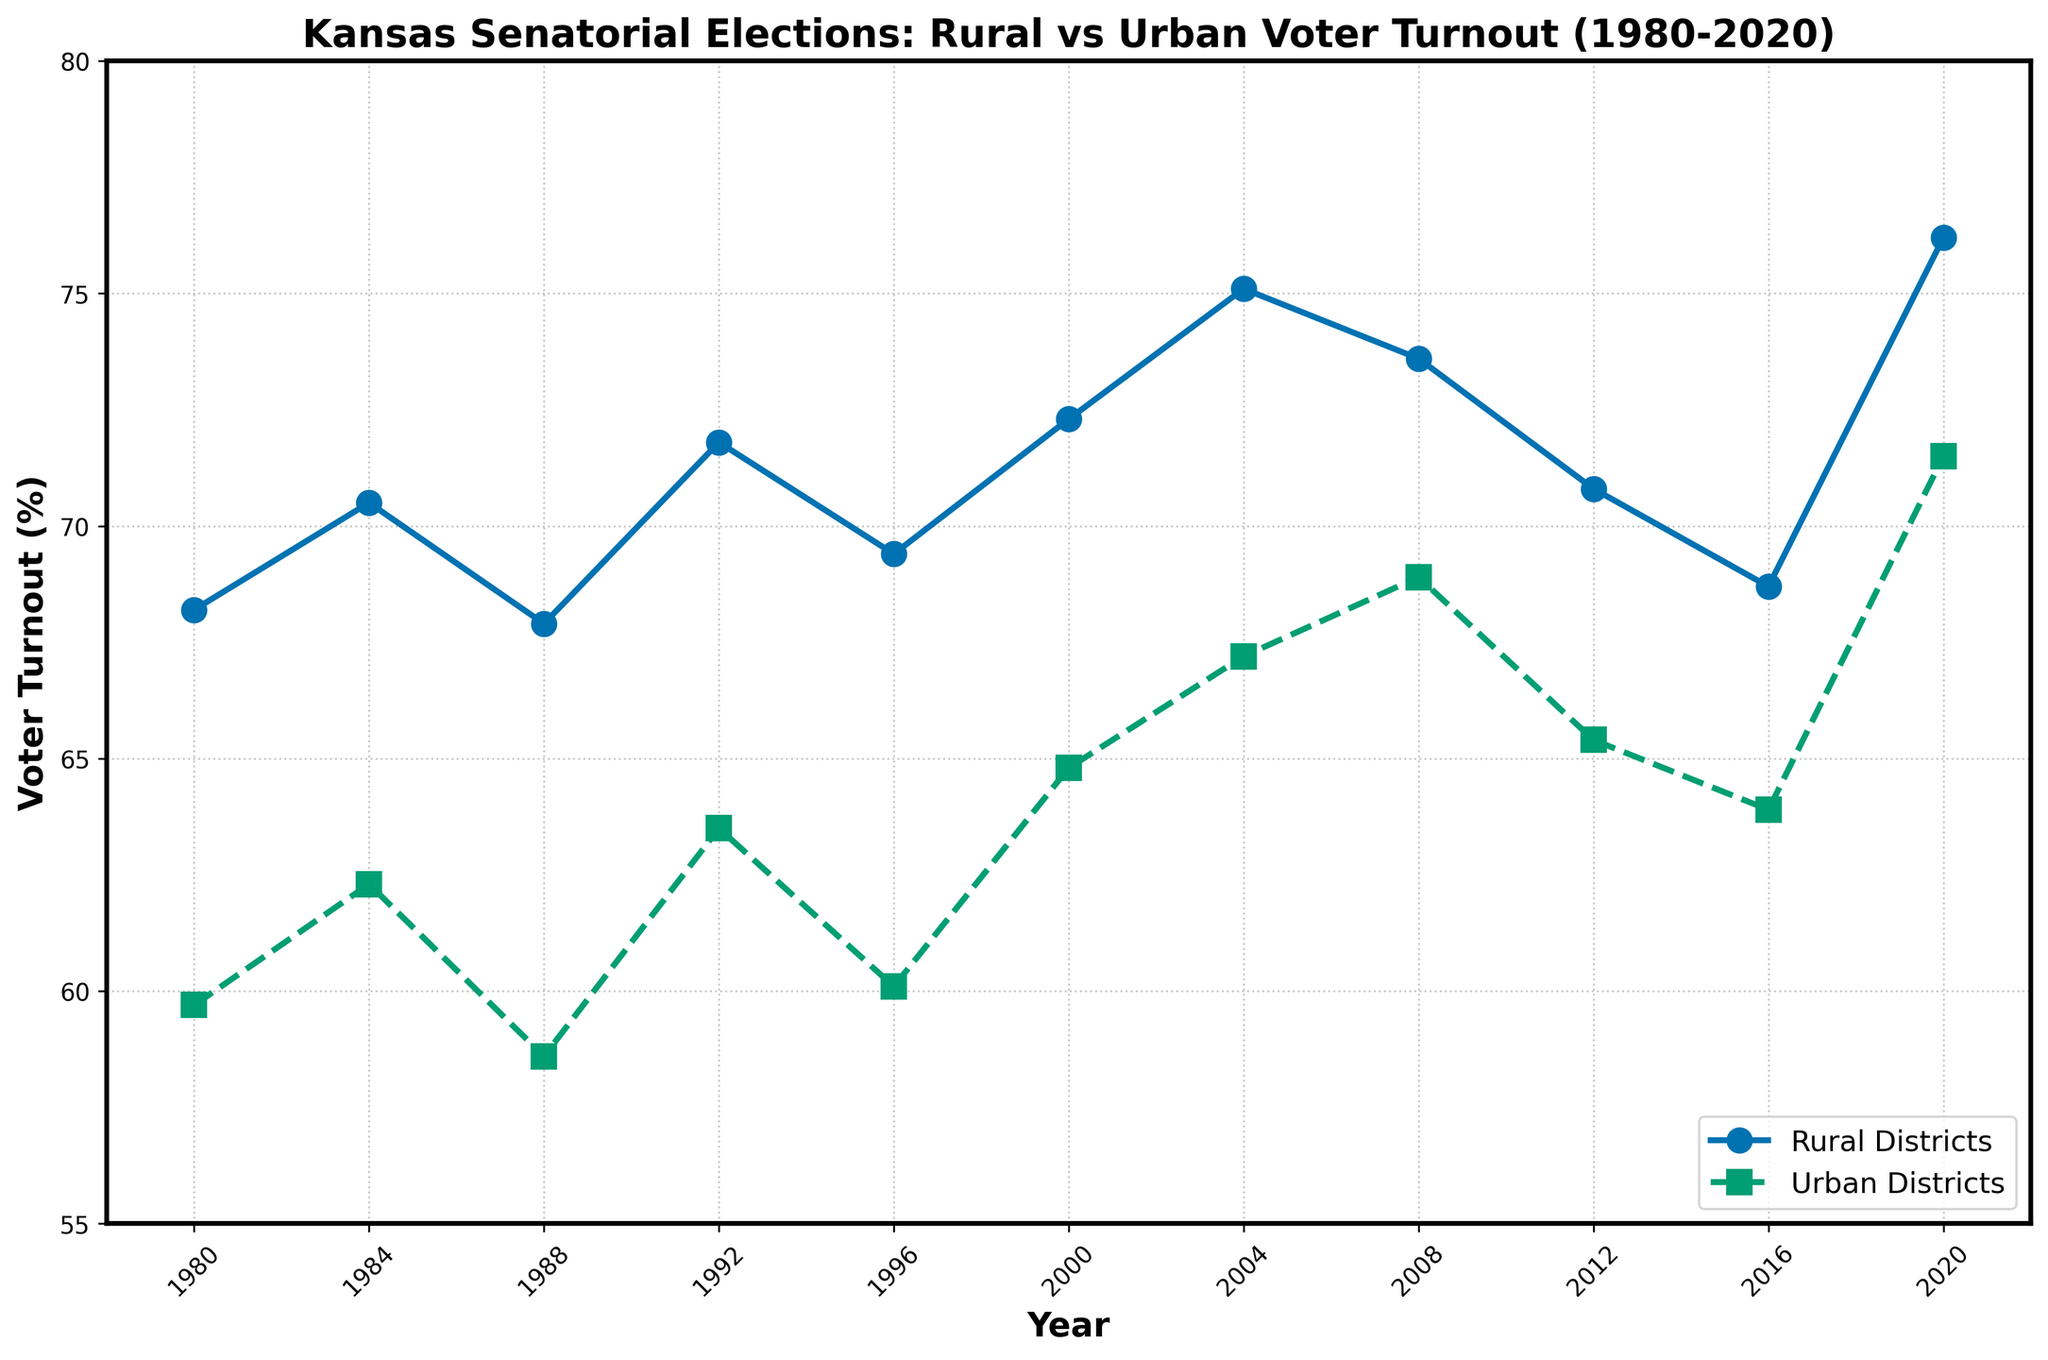How much did voter turnout in rural districts increase from 1980 to 2020? The voter turnout in rural districts in 1980 was 68.2%, and it increased to 76.2% in 2020. The difference is 76.2% - 68.2% = 8%.
Answer: 8% How do the voter turnout percentages in urban districts in 2000 and 2004 compare? The voter turnout in urban districts in 2000 was 64.8%, and in 2004 it was 67.2%. Therefore, the turnout in 2004 was higher by 67.2% - 64.8% = 2.4%.
Answer: 2.4% Between rural and urban districts, which had the higher voter turnout in the year 2016? In 2016, the voter turnout in rural districts was 68.7%, whereas in urban districts it was 63.9%. Rural districts had a higher voter turnout.
Answer: Rural districts What is the average voter turnout for both rural and urban districts across all the years depicted? To find the average voter turnout: sum all percentages for rural and urban districts, then divide by the number of years (11). The sum for rural districts is (68.2+70.5+67.9+71.8+69.4+72.3+75.1+73.6+70.8+68.7+76.2) = 784.5, and the average is 784.5 / 11 = 71.3%. The sum for urban districts is (59.7+62.3+58.6+63.5+60.1+64.8+67.2+68.9+65.4+63.9+71.5) = 705.9, and the average is 705.9 / 11 = 64.2%.
Answer: Rural: 71.3%, Urban: 64.2% In which year did the rural districts see their highest voter turnout? By looking at the plot, the highest point for rural districts is in the year 2020, with a turnout of 76.2%.
Answer: 2020 How did the voter turnout in urban districts change between 1980 and 1992? In 1980, the urban voter turnout was 59.7%. In 1992, it was 63.5%. The change is 63.5% - 59.7% = 3.8%.
Answer: 3.8% In general, which districts saw a higher voter turnout over the period from 1980 to 2020? Observing the entire span of years in the plot, rural districts consistently had higher voter turnout percentages compared to urban districts.
Answer: Rural districts 